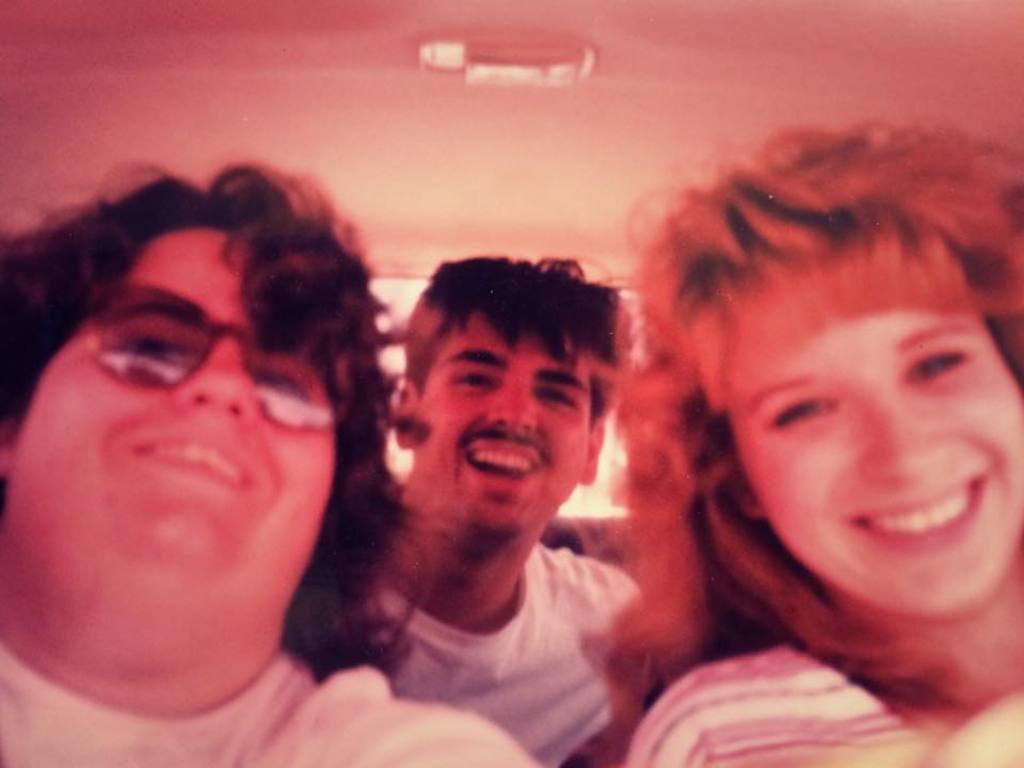How many people are present in the image? There are three people in the image. What are the three people doing in the image? The three people are looking at someone and laughing. What type of goose can be seen in the garden in the image? There is no goose or garden present in the image; it features three people looking at someone and laughing. What discovery was made by the people in the image? There is no indication of a discovery being made in the image; the three people are simply looking at someone and laughing. 